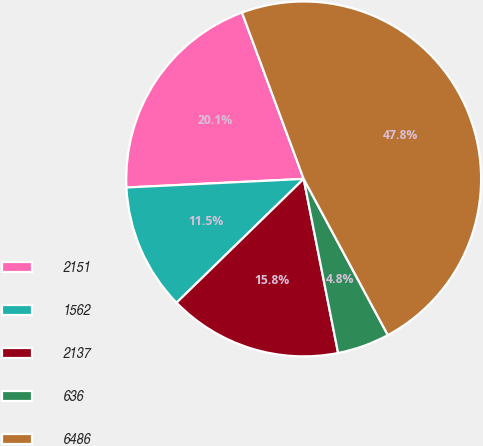Convert chart to OTSL. <chart><loc_0><loc_0><loc_500><loc_500><pie_chart><fcel>2151<fcel>1562<fcel>2137<fcel>636<fcel>6486<nl><fcel>20.12%<fcel>11.52%<fcel>15.82%<fcel>4.76%<fcel>47.79%<nl></chart> 